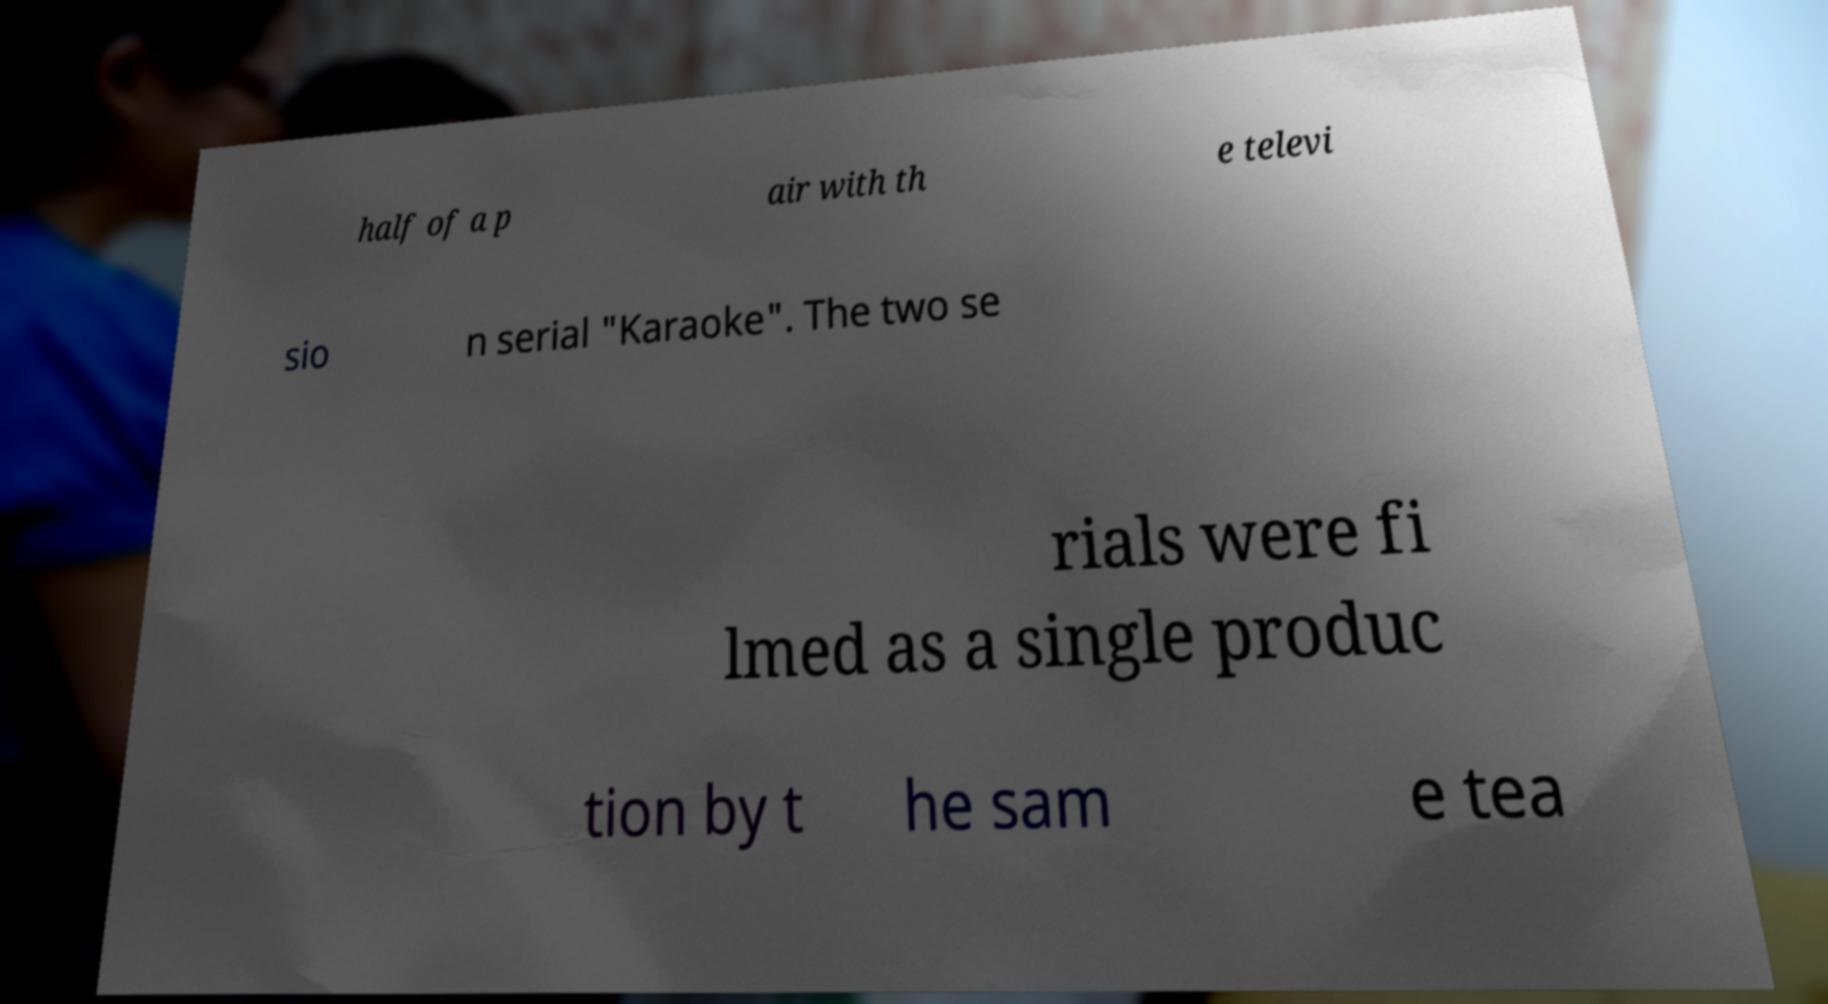Please read and relay the text visible in this image. What does it say? half of a p air with th e televi sio n serial "Karaoke". The two se rials were fi lmed as a single produc tion by t he sam e tea 